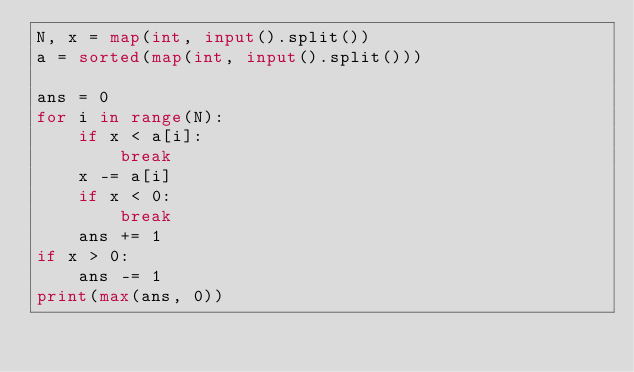Convert code to text. <code><loc_0><loc_0><loc_500><loc_500><_Python_>N, x = map(int, input().split())
a = sorted(map(int, input().split()))

ans = 0
for i in range(N):
    if x < a[i]:
        break
    x -= a[i]
    if x < 0:
        break
    ans += 1
if x > 0:
    ans -= 1
print(max(ans, 0))</code> 